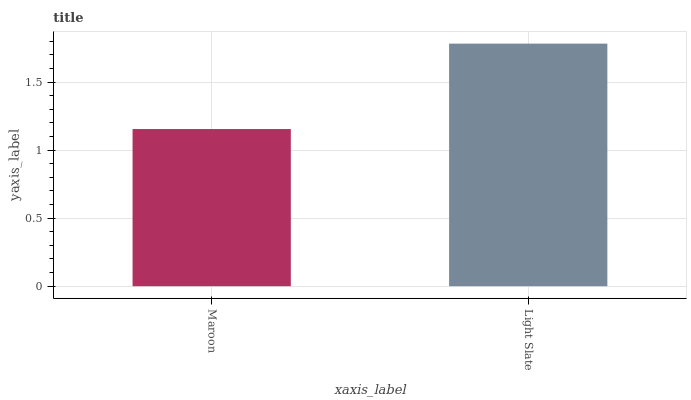Is Maroon the minimum?
Answer yes or no. Yes. Is Light Slate the maximum?
Answer yes or no. Yes. Is Light Slate the minimum?
Answer yes or no. No. Is Light Slate greater than Maroon?
Answer yes or no. Yes. Is Maroon less than Light Slate?
Answer yes or no. Yes. Is Maroon greater than Light Slate?
Answer yes or no. No. Is Light Slate less than Maroon?
Answer yes or no. No. Is Light Slate the high median?
Answer yes or no. Yes. Is Maroon the low median?
Answer yes or no. Yes. Is Maroon the high median?
Answer yes or no. No. Is Light Slate the low median?
Answer yes or no. No. 